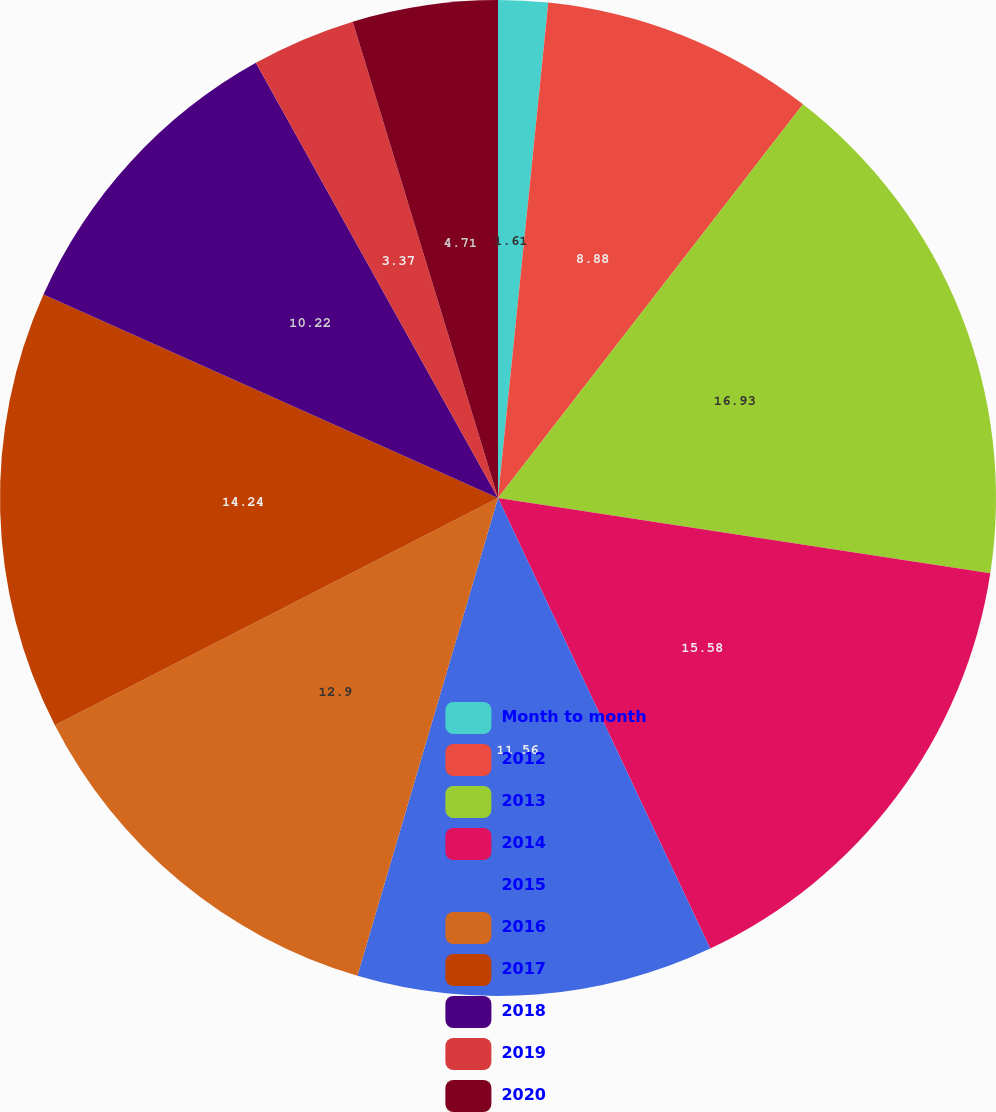Convert chart. <chart><loc_0><loc_0><loc_500><loc_500><pie_chart><fcel>Month to month<fcel>2012<fcel>2013<fcel>2014<fcel>2015<fcel>2016<fcel>2017<fcel>2018<fcel>2019<fcel>2020<nl><fcel>1.61%<fcel>8.88%<fcel>16.92%<fcel>15.58%<fcel>11.56%<fcel>12.9%<fcel>14.24%<fcel>10.22%<fcel>3.37%<fcel>4.71%<nl></chart> 